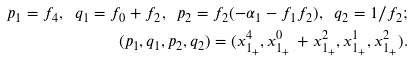Convert formula to latex. <formula><loc_0><loc_0><loc_500><loc_500>p _ { 1 } = f _ { 4 } , \ q _ { 1 } = f _ { 0 } + f _ { 2 } , \ p _ { 2 } = f _ { 2 } ( - \alpha _ { 1 } - f _ { 1 } f _ { 2 } ) , \ q _ { 2 } = 1 / f _ { 2 } ; \\ ( p _ { 1 } , q _ { 1 } , p _ { 2 } , q _ { 2 } ) = ( x _ { 1 _ { + } } ^ { 4 } , x _ { 1 _ { + } } ^ { 0 } \, + x _ { 1 _ { + } } ^ { 2 } , x _ { 1 _ { + } } ^ { 1 } , x _ { 1 _ { + } } ^ { 2 } ) .</formula> 